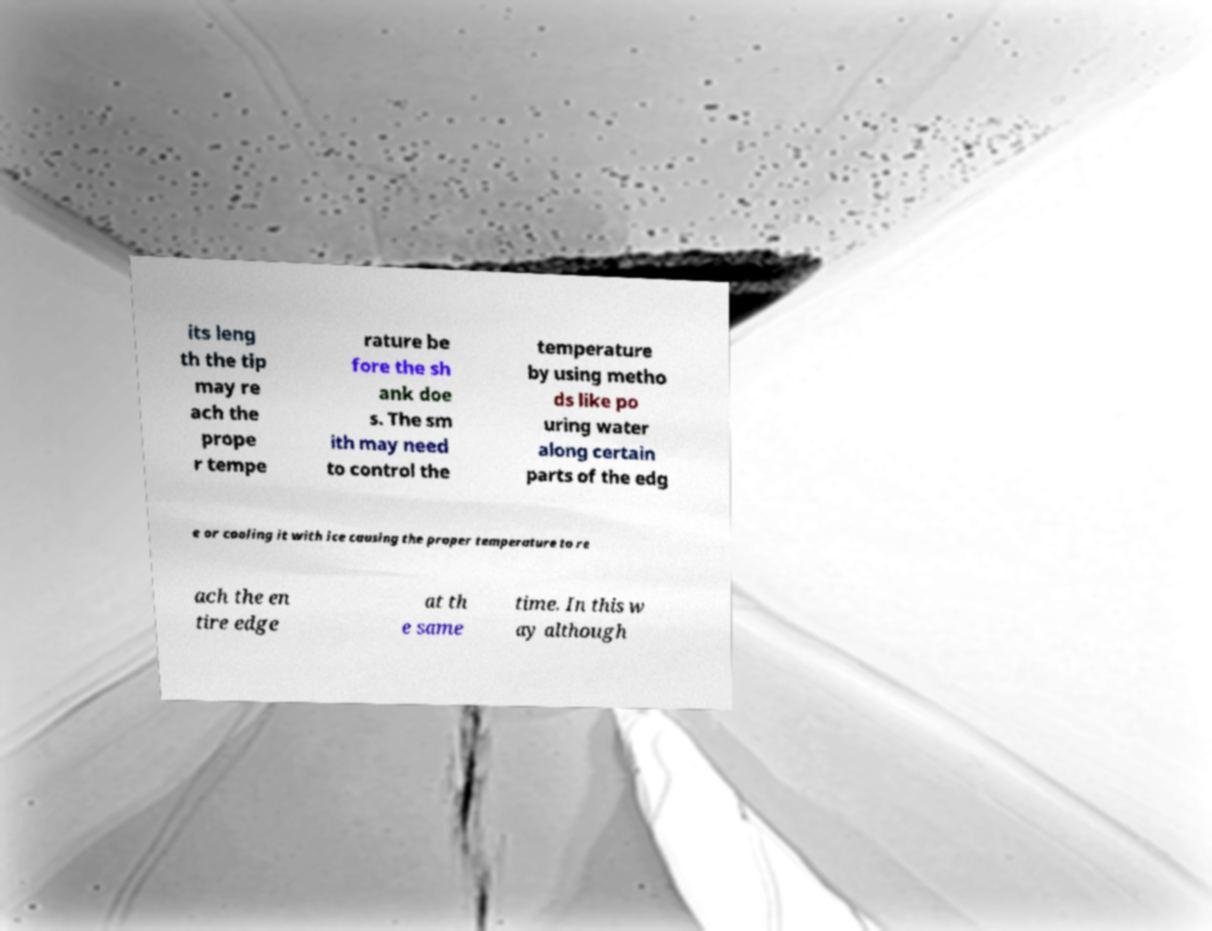There's text embedded in this image that I need extracted. Can you transcribe it verbatim? its leng th the tip may re ach the prope r tempe rature be fore the sh ank doe s. The sm ith may need to control the temperature by using metho ds like po uring water along certain parts of the edg e or cooling it with ice causing the proper temperature to re ach the en tire edge at th e same time. In this w ay although 